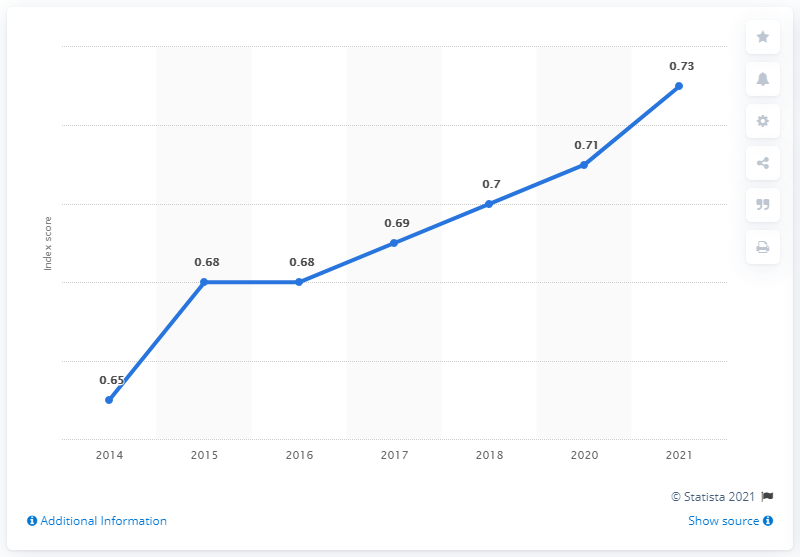List a handful of essential elements in this visual. Since 2014, the gender gap index in Suriname has been increasing. 